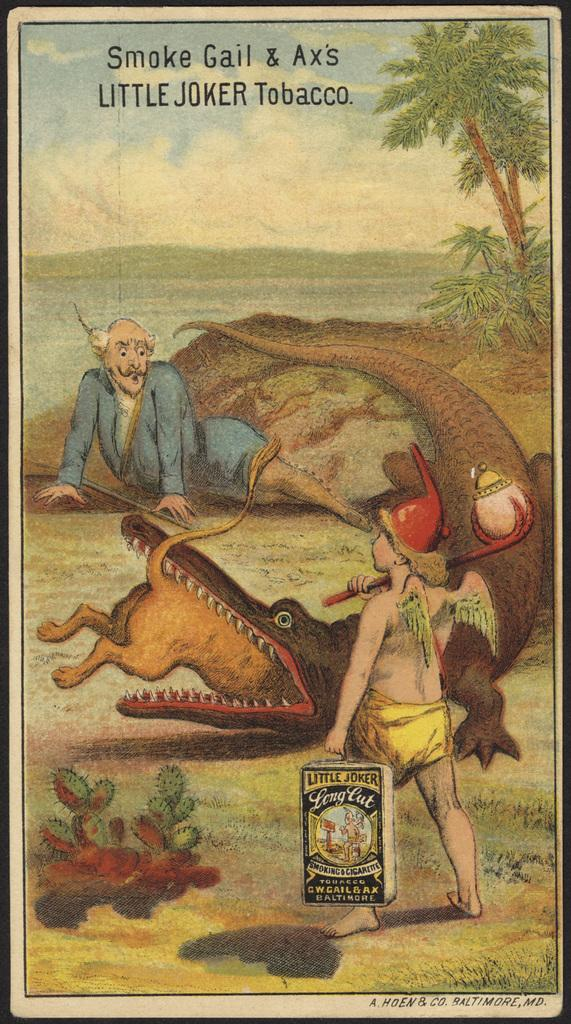What type of animal is in the image? There is a crocodile in the image. Who else is present in the image besides the crocodile? There is a man and a kid in the image. What can be seen at the top of the image? The sky is visible at the top of the image. What type of vegetation is on the right side of the image? There are trees on the right side of the image. What type of stew is being prepared by the crocodile in the image? There is no indication in the image that a crocodile is preparing stew, nor is there any evidence of cooking or food preparation. 